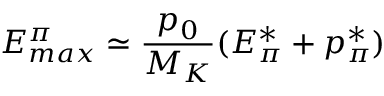<formula> <loc_0><loc_0><loc_500><loc_500>E _ { \max } ^ { \pi } \simeq \frac { p _ { 0 } } { M _ { K } } ( E _ { \pi } ^ { * } + p _ { \pi } ^ { * } )</formula> 